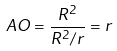<formula> <loc_0><loc_0><loc_500><loc_500>A O = \frac { R ^ { 2 } } { R ^ { 2 } / r } = r</formula> 